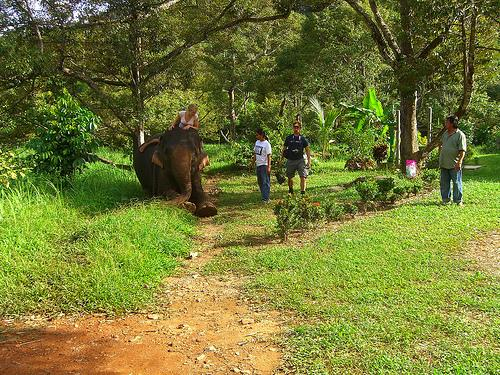Describe the types of plants and trees visible in the image. There are bright green plants, flowering plants in a row, tall green grass, rocks embedded in a footpath, and trees of various sizes in the image. Explain the primary action happening within the image and why it may be interesting. The primary action is the woman riding an elephant in the wild; it is interesting due to the adventure and thrill it represents, as well as the relationship between humans and animals. Count the number of people present in the image and describe their attire. There are four people - one woman in a white t-shirt riding the elephant, two men standing, one in a green shirt and the other in a white shirt with shorts, and the third man wearing blue jeans. Explain the interaction between the people and the animal in the image. The interaction includes a woman riding on the elephant's back and two men watching her ride, likely expressing amazement or curiosity. Give the total count of men, women, and animals featured in the image. There are three men, one woman, and one elephant in the image. Identify the nature element which forms the backdrop of the image and its dominating color. The nature element in the backdrop is tall green grass, forming a lush green surrounding. Describe the image in a single sentence that conveys its most captivating aspect. A group of onlookers watch as a woman enjoys a thrilling ride atop a majestic elephant amidst a lush forest setting. Rate the image quality from a scale of 1 to 10. 7 - the image is well composed with clear objects and interesting interactions but could have better lighting or focus. Provide a brief description of the primary object in the image and its surroundings. An elephant in the woods is surrounded by green grass, a dirt path, and people watching a woman riding on its back. Identify the primary emotion or sentiment conveyed by the image. The image conveys a sense of adventure and fun, as the woman rides the elephant and others watch. Did you notice a bicycle leaning against one of the trees? There is no mention of a bicycle in any of the image information. This instruction uses an interrogative sentence to cause the user to doubt their own observation and search for a non-existent object. Where is the bag resting in the image? leaning against tree List the types of plants mentioned in the image. green grass, tall green grass, bright green plants, flowering plants, plants with large leaves What is the main activity involving the elephant and the woman? woman riding an elephant Interpret the layout of the trees in the image. trees in varying sizes scattered throughout a forest Identify the fashion choices of each person in the image. man in green shirt, man in white shirt, man in shorts, woman in white shirt There's a person wearing differently colored shirts in the image. One of them is green, what's the other color?  white Find a group of children playing near the elephant. No, it's not mentioned in the image. Are there any odd shaped trees in the image? Yes Explain the relationship between the people and the elephant. men watching a woman riding an elephant Create a short story describing an interaction between the characters in the image. In the heart of the forest, a group of friends ventured off the beaten path, and one brave woman decided to ride the mysterious elephant they encountered. The men watched in awe, admiring her courageous spirit as she connected with nature — an unforgettable memory etched in their minds forever. What is the main animal in the image? elephant Do you see any birds flying above the trees in the forest? There are no birds mentioned in the provided information. The interrogative sentence makes the user question the presence of birds in the image when they are not there. Where is the white t-shirt located in relation to the woman riding an elephant in the image? next to the elephant How could this scene be connected to the local ecology and any known studies in the area? The presence of an elephant shows a rich ecosystem and possibly a research program on human-animal interaction and conservation. Identify and describe the non-human animal present in the scene. an elephant in the woods Identify any text in the image. no text present Is there any specific event depicted in the image involving the people and the elephant? woman riding an elephant while men watch Describe the image in a single sentence using a poetic style. In a sun-dappled forest glade, awestruck men behold a woman gracefully perched atop an enigmatic elephant. 